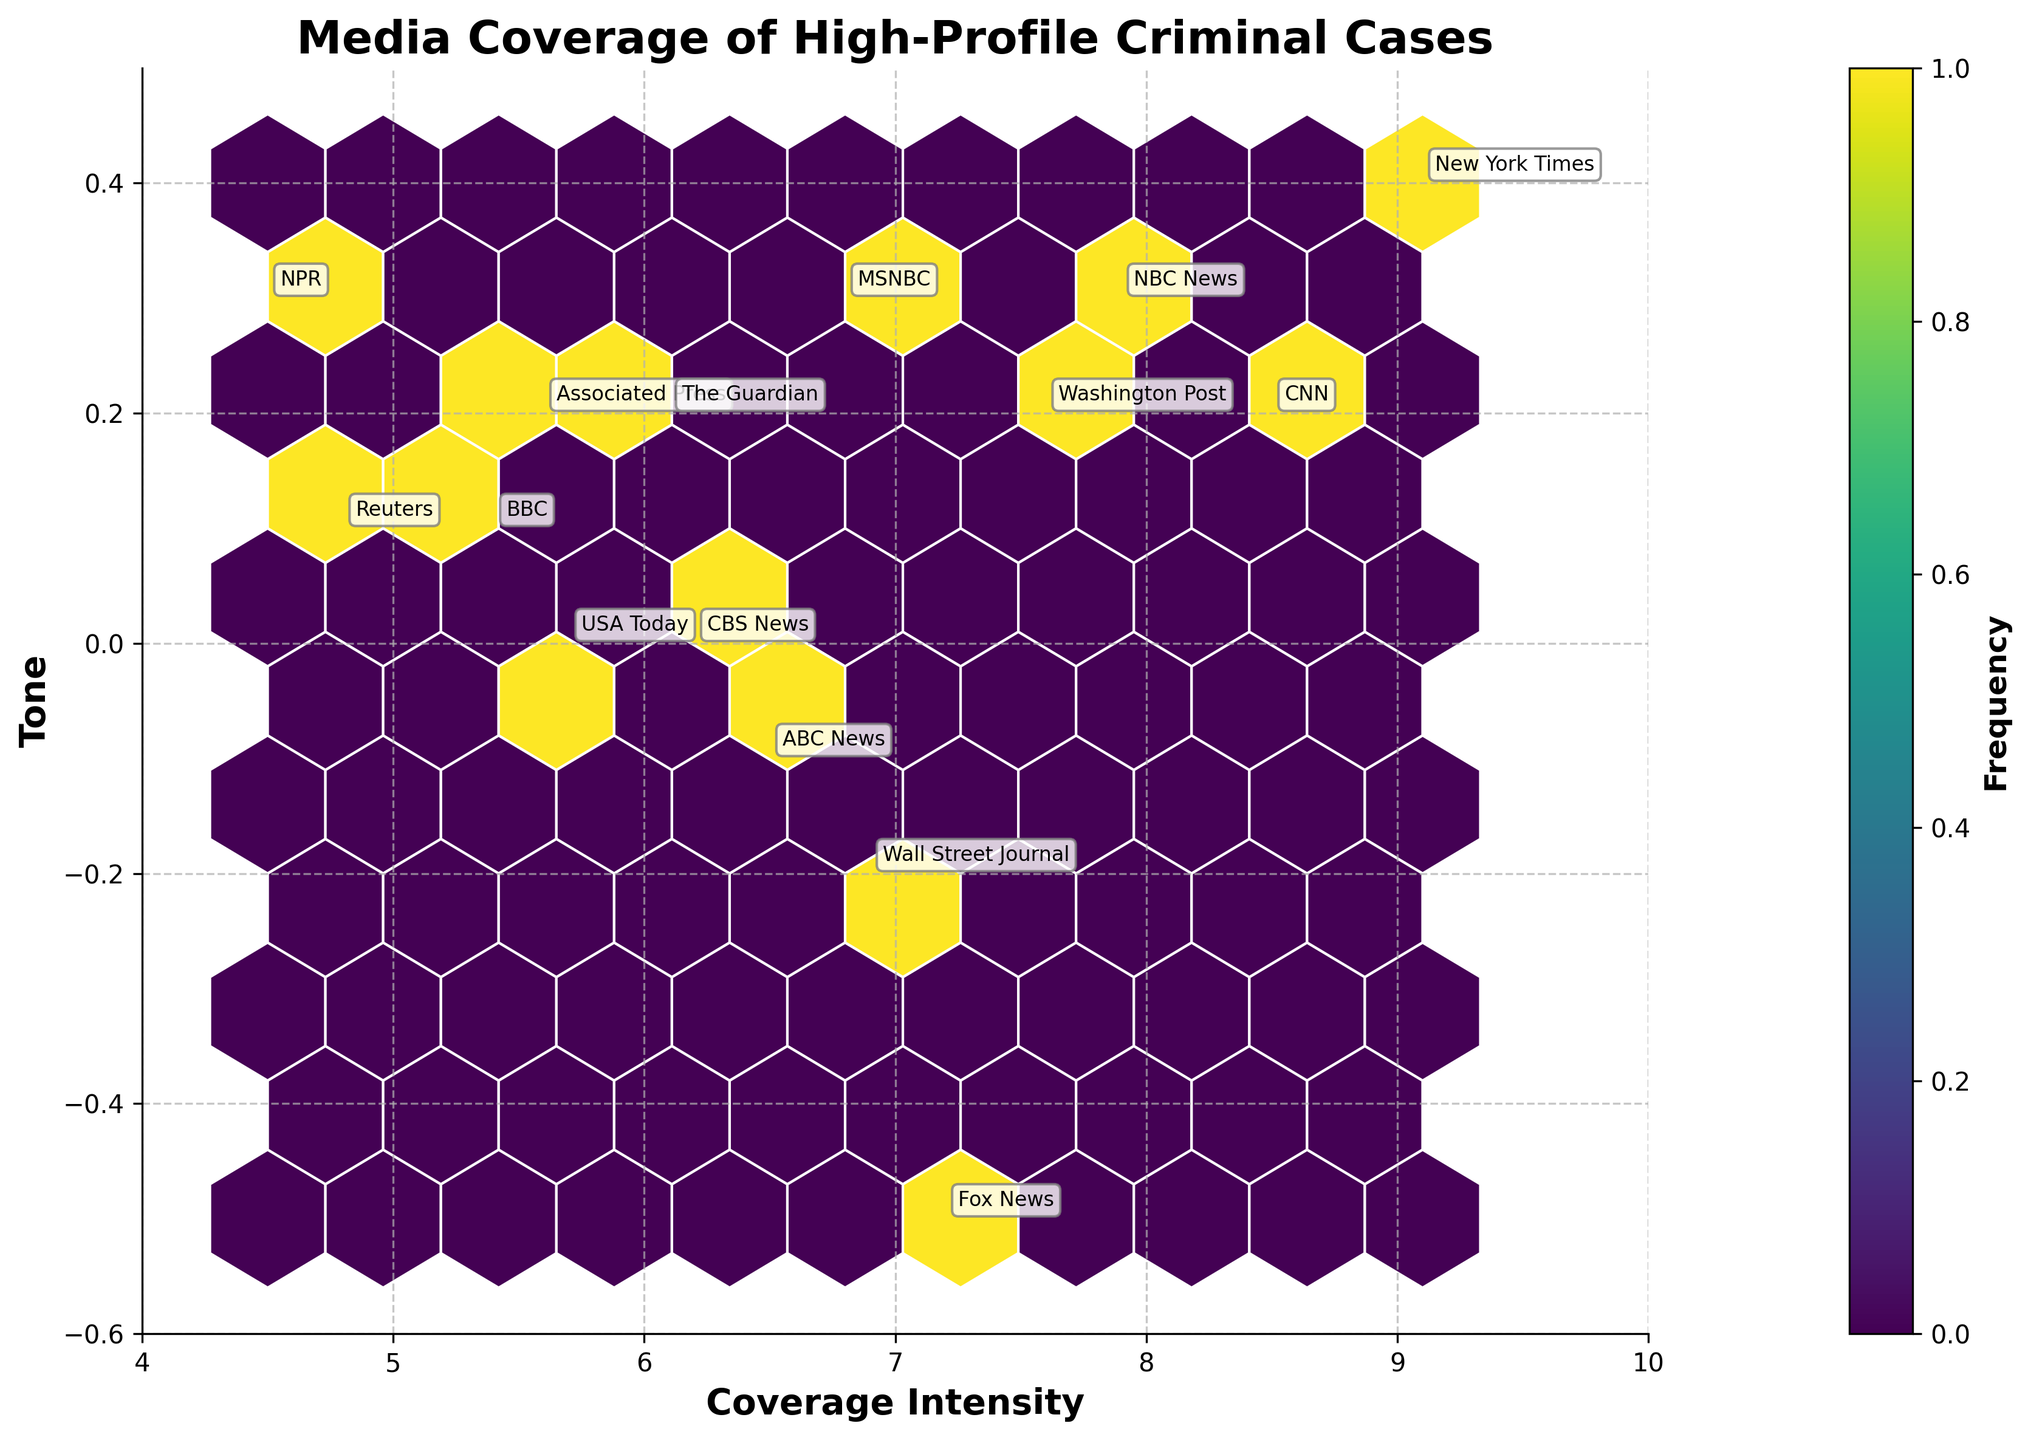What is the title of the figure? The title is displayed prominently at the top of the figure.
Answer: Media Coverage of High-Profile Criminal Cases Which news outlet has the highest coverage intensity? The data points are annotated with news outlets on the plot. By examining the x-axis (Coverage Intensity), we can identify that "New York Times" has the highest coverage intensity with a value of 9.1.
Answer: New York Times What is the tone of Fox News’ coverage of the Casey Anthony Case? Locate the data point annotated with "Fox News." Inspect the y-axis label (Tone) for the corresponding value of this point. The plot indicates it has a tone value of -0.5.
Answer: -0.5 Among the news outlets with a tone range between -0.1 and 0.3, which one has the highest coverage intensity? Locate and filter points within the y-axis range of -0.1 to 0.3. Compare the coverage intensity (x-axis) values for these points. "New York Times" with a tone of 0.4 and the highest coverage intensity of 9.1 falls within this range.
Answer: New York Times How frequently occurring (dense) is the coverage intensity between 6 and 8 with a tone between 0.1 and 0.3? Review the color gradient in the hexagonal bins within the specified coverage intensity and tone range. Darker colors indicate higher frequencies. The densest area is around these values, showing a higher frequency.
Answer: High Which case has the most positive tone? Check the y-axis label for the highest positive tone value and find the corresponding case label at that point. "New York Times" covers the "George Zimmerman Trial" with a tone of 0.4, the highest on the plot.
Answer: George Zimmerman Trial What is the average coverage intensity for news outlets with a tone below zero? Identify and note the coverage intensity (x-axis) values and respective tones below zero, then calculate the average. Values: 7.2, 6.5, 6.2, 6.9. Sum = 26.8, count = 4, average = 26.8 / 4 = 6.7
Answer: 6.7 Does BBC have a more positive tone of coverage compared to MSNBC? Compare the tones (y-axis values) for BBC and MSNBC. BBC has a tone of 0.1, while MSNBC has 0.3.
Answer: No What is the range of coverage intensity displayed on the x-axis? The x-axis limits can be directly read from the plot. They extend from 4 to 10.
Answer: 4 to 10 How does NPR’s coverage compare in tone with Wall Street Journal's? By locating the points for NPR and Wall Street Journal and comparing their y-axis values (tones). NPR has a tone of 0.3, and Wall Street Journal has -0.2. Thus, NPR has a more positive tone.
Answer: NPR has a more positive tone 